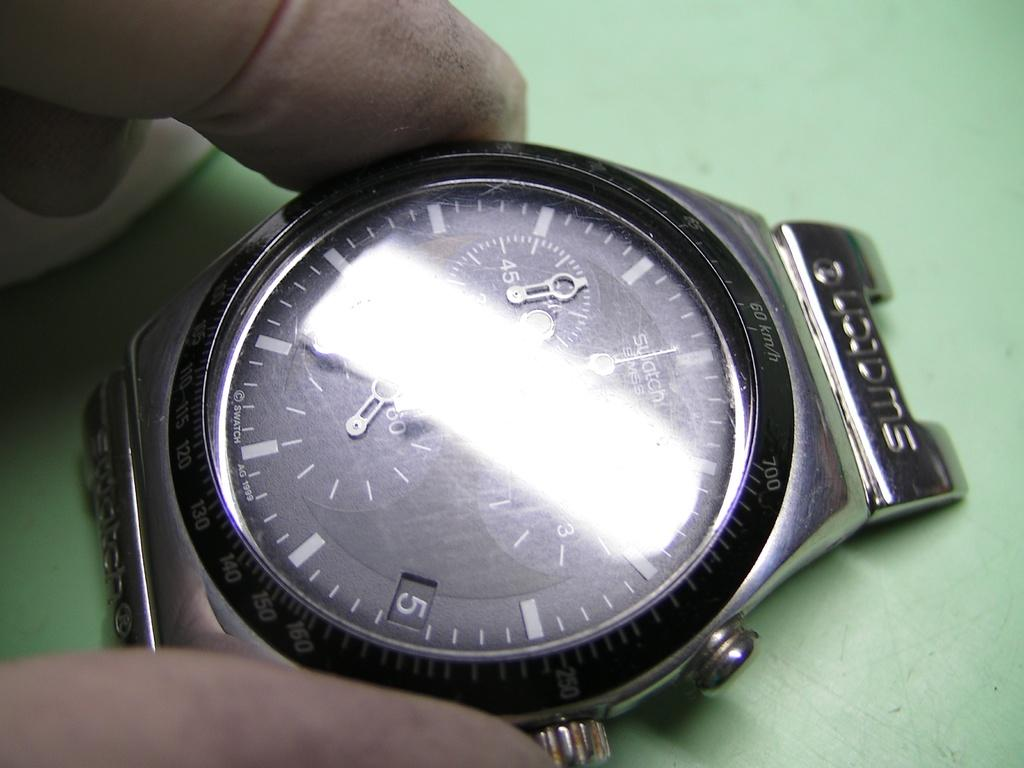<image>
Render a clear and concise summary of the photo. Part of a watch with 60km/h written on it. 